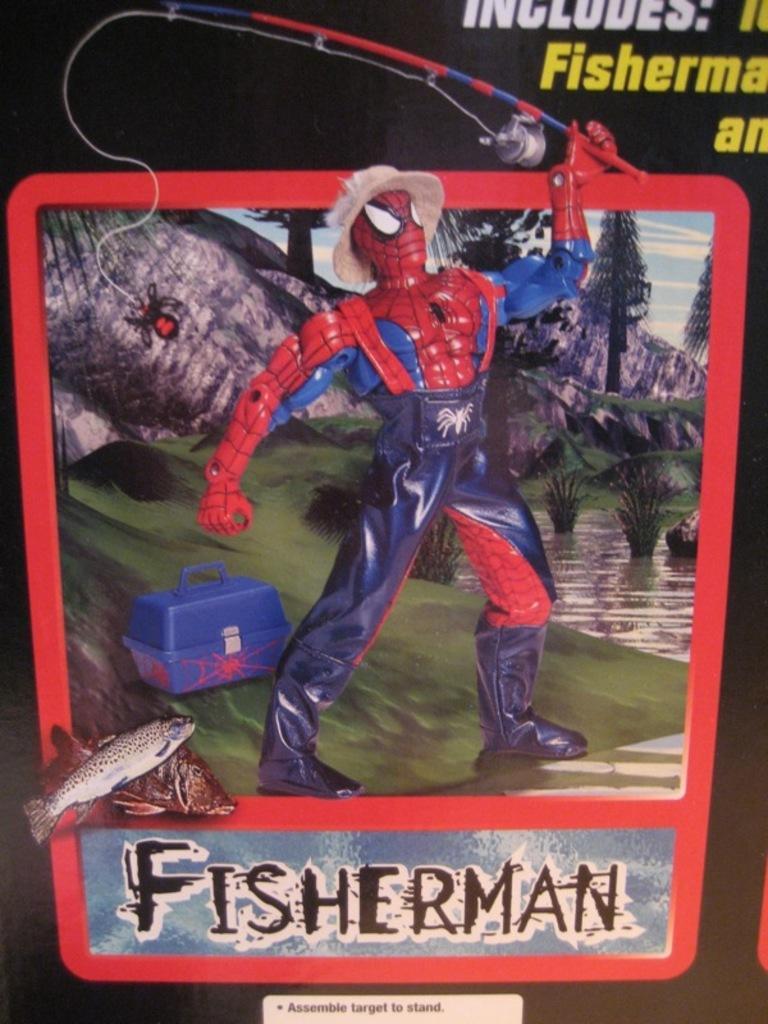Can you describe this image briefly? As we can see in the image there is a banner. On banner there is a man, suitcase, water, trees, sky and something written. 